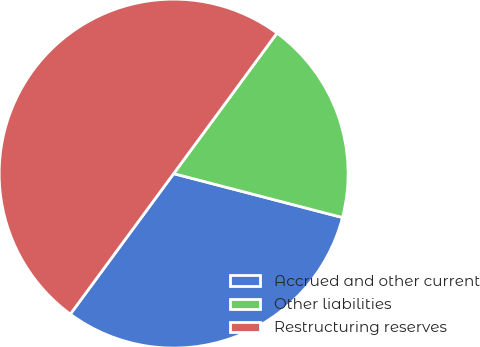Convert chart to OTSL. <chart><loc_0><loc_0><loc_500><loc_500><pie_chart><fcel>Accrued and other current<fcel>Other liabilities<fcel>Restructuring reserves<nl><fcel>31.04%<fcel>18.96%<fcel>50.0%<nl></chart> 